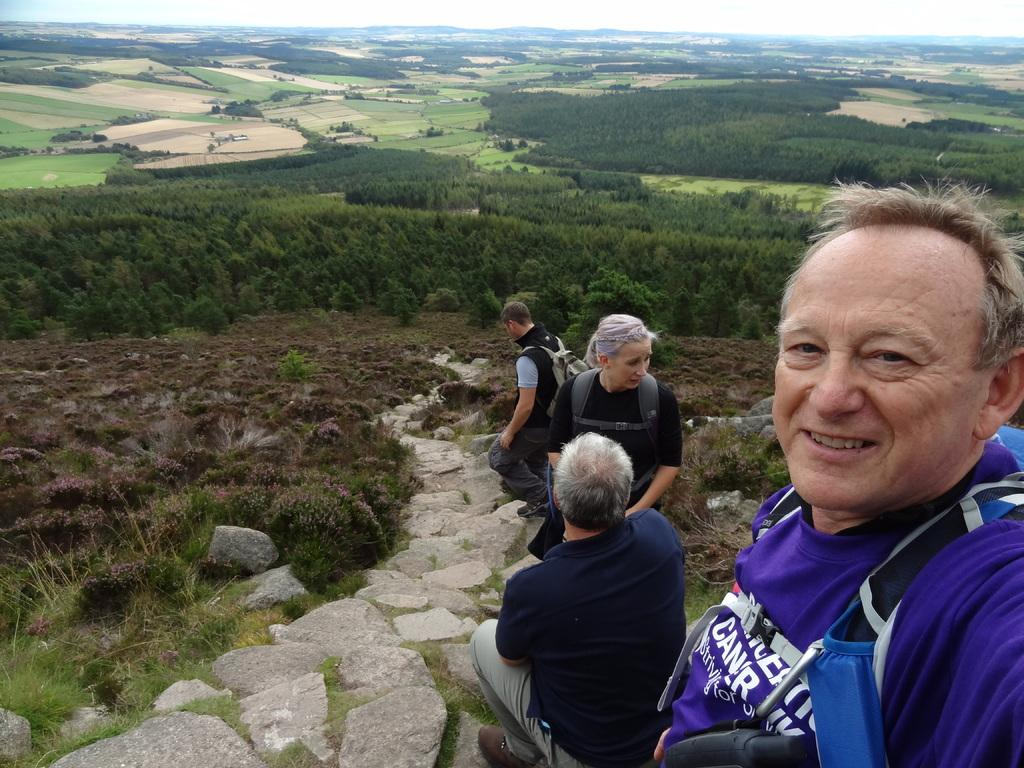What is the main subject of the image? There is a group of people on the ground. What type of terrain can be seen in the image? Stones, grass, plants, and rocks are visible in the image. What type of vegetation is present in the image? There is a group of trees in the image. What part of the natural environment is visible in the image? The sky is visible in the image. What type of clover is being used as a hat by the woman in the image? There is no woman or clover present in the image. What type of basin is being used to collect rainwater in the image? There is no basin present in the image. 